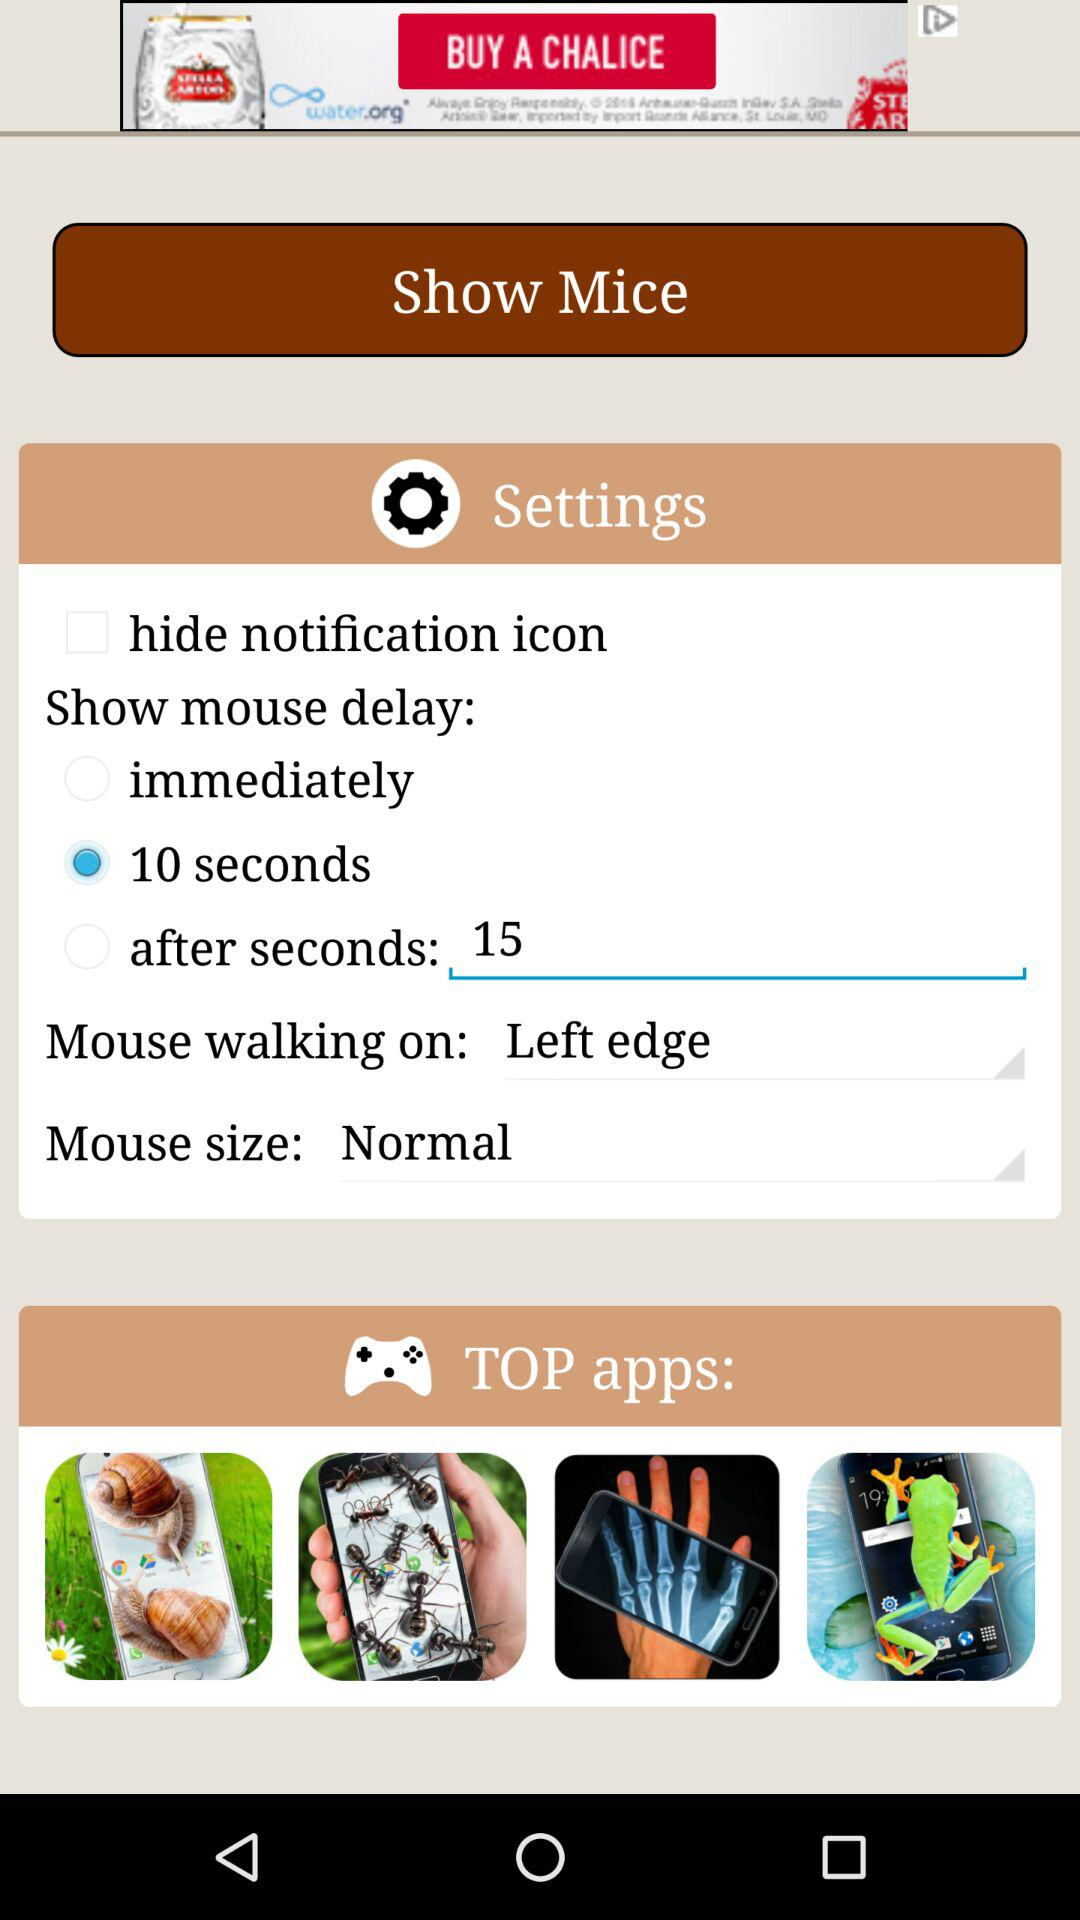What is the current status of the "hide notification icon"? The current status of the "hide notification icon" is "off". 